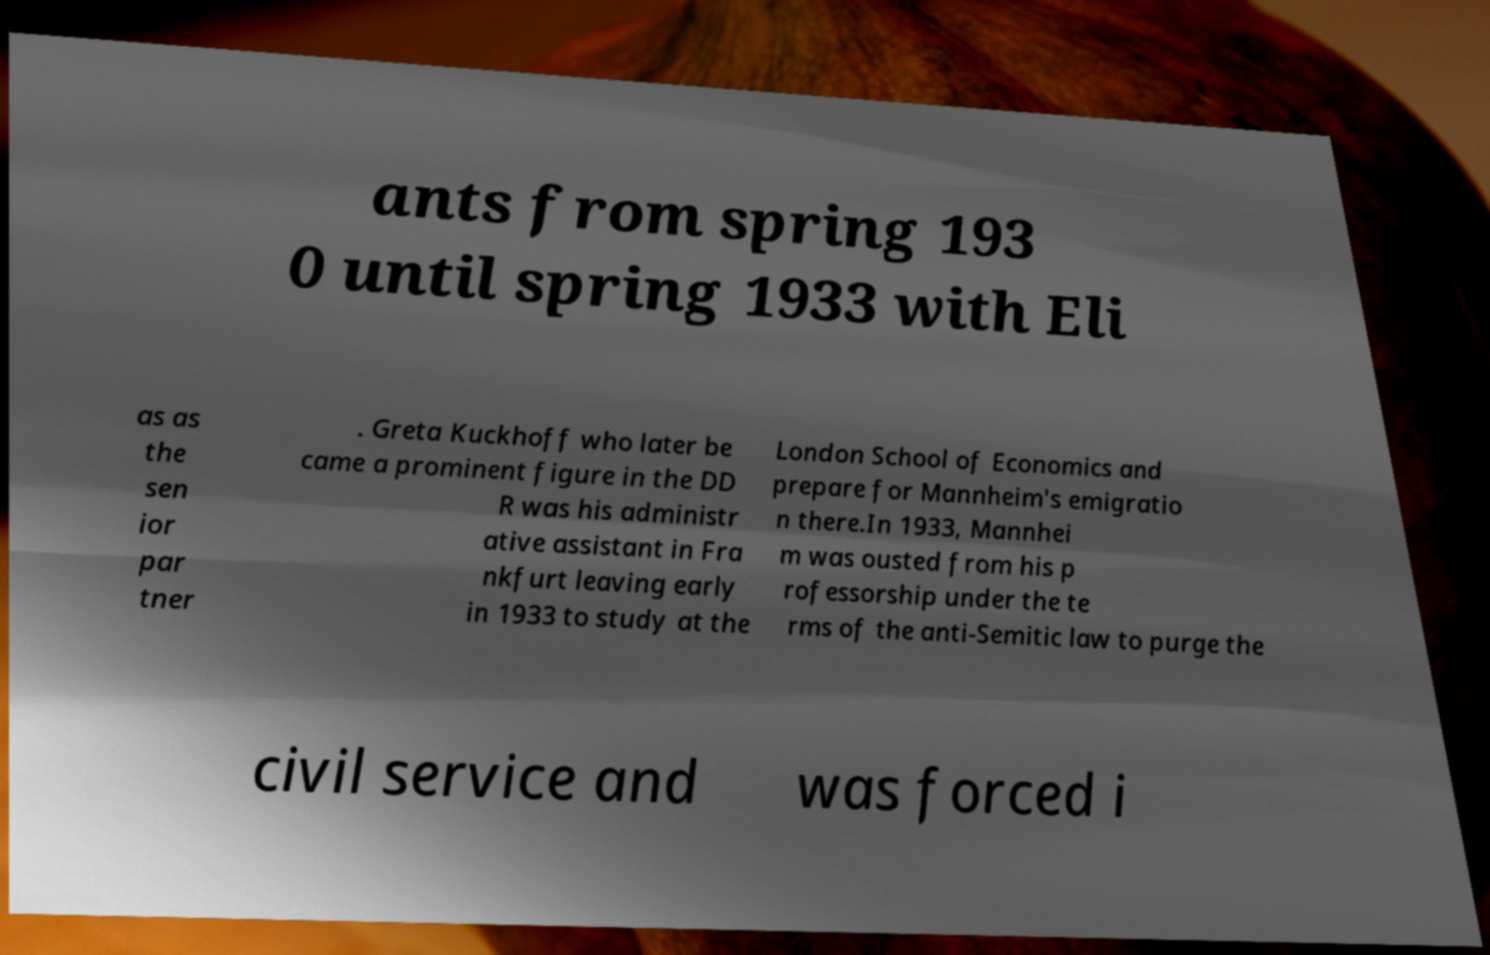I need the written content from this picture converted into text. Can you do that? ants from spring 193 0 until spring 1933 with Eli as as the sen ior par tner . Greta Kuckhoff who later be came a prominent figure in the DD R was his administr ative assistant in Fra nkfurt leaving early in 1933 to study at the London School of Economics and prepare for Mannheim's emigratio n there.In 1933, Mannhei m was ousted from his p rofessorship under the te rms of the anti-Semitic law to purge the civil service and was forced i 